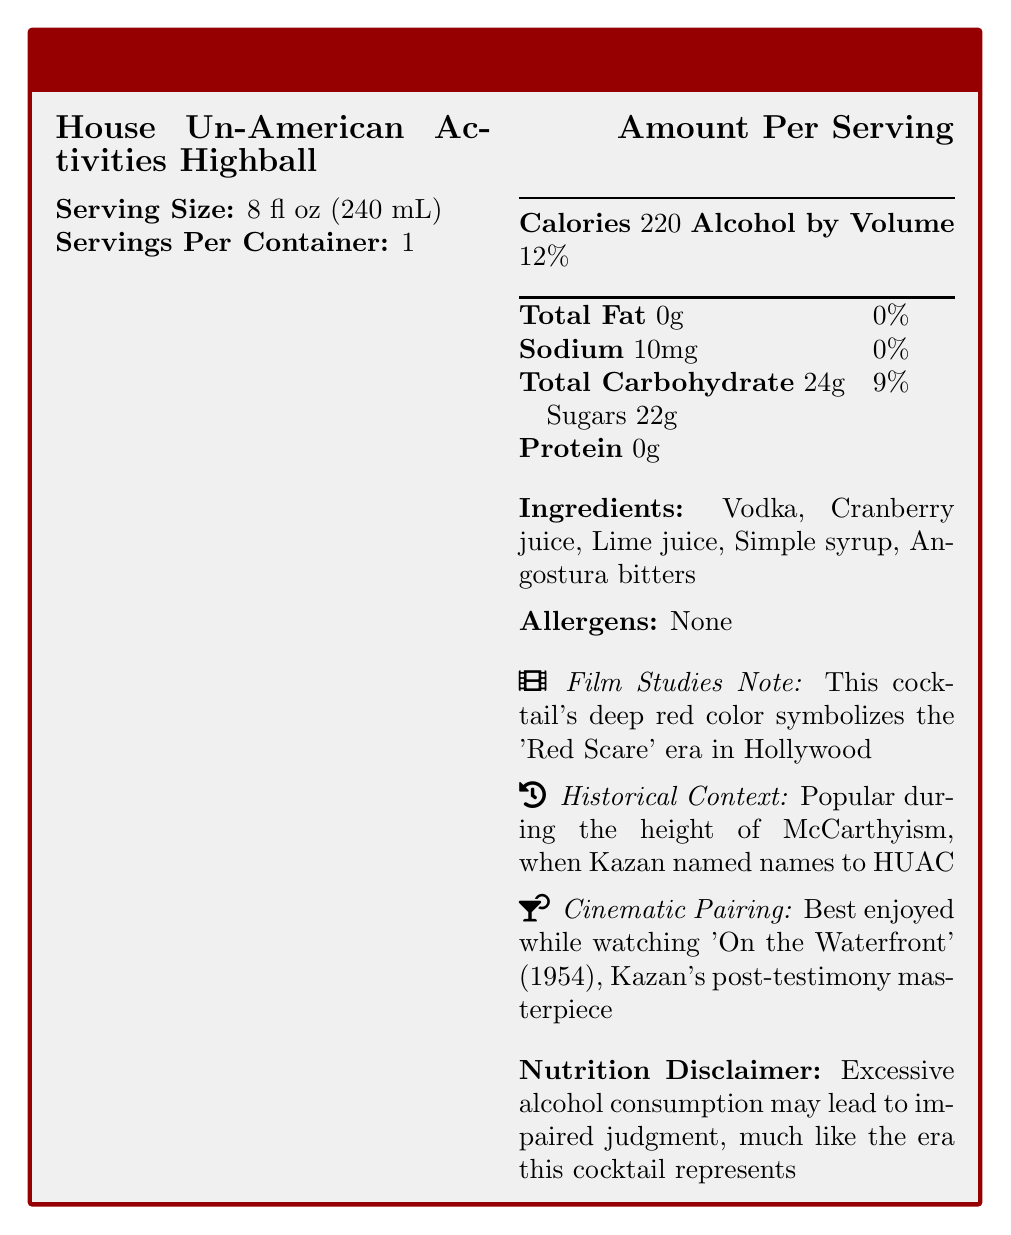what is the serving size for the House Un-American Activities Highball? The document specifies that the serving size for this cocktail is 8 fl oz (240 mL).
Answer: 8 fl oz (240 mL) how many calories are in one serving of the House Un-American Activities Highball? The document lists the calorie content as 220 per serving.
Answer: 220 what is the percentage of daily value of total carbohydrate in one serving? The document states that the total carbohydrate makes up 9% of the daily value.
Answer: 9% name three ingredients in the House Un-American Activities Highball? The ingredients listed in the document include Vodka, Cranberry juice, Lime juice, Simple syrup, and Angostura bitters.
Answer: Vodka, Cranberry juice, Lime juice does the House Un-American Activities Highball contain any allergens? The document clearly states that there are no allergens in the cocktail.
Answer: None what is the alcohol by volume (ABV) percentage of the House Un-American Activities Highball? The document mentions that the alcohol by volume is 12%.
Answer: 12% what film is recommended to enjoy while drinking the House Un-American Activities Highball? A. 'A Streetcar Named Desire' B. 'East of Eden' C. 'On the Waterfront' D. 'Gentleman's Agreement' The document suggests that the cocktail is best enjoyed while watching 'On the Waterfront' (1954).
Answer: C how much sodium is present in one serving of the House Un-American Activities Highball? The nutrition facts specify that there are 10mg of sodium per serving.
Answer: 10mg which historical period does the House Un-American Activities Highball relate to? A. The Great Depression B. The Cold War C. McCarthyism D. The Civil Rights Movement According to the document, the cocktail is associated with the height of McCarthyism.
Answer: C does the House Un-American Activities Highball contain protein? The document indicates that the protein content of the cocktail is 0g.
Answer: No can the exact amount of Angostura bitters used be determined from the document? The document lists Angostura bitters as an ingredient but does not specify the amount used.
Answer: Cannot be determined does the document provide a disclaimer regarding alcohol consumption? The document contains a disclaimer stating that excessive alcohol consumption may lead to impaired judgment, similar to the era it represents.
Answer: Yes how does the document explain the red color of the House Un-American Activities Highball? According to the document, the red color is symbolic of the 'Red Scare' era.
Answer: The deep red color symbolizes the 'Red Scare' era in Hollywood summarize the main idea of the document in one sentence. The document features details about serving size, ingredients, nutritional content, historical context, and a film pairing suggestion, reflecting on the symbolism and implications of the cocktail's elements.
Answer: The document provides nutritional information and contextual background for the House Un-American Activities Highball, a cocktail inspired by the McCarthyism era, while noting its symbolic significance and a suggestion to pair it with the film 'On the Waterfront.' 